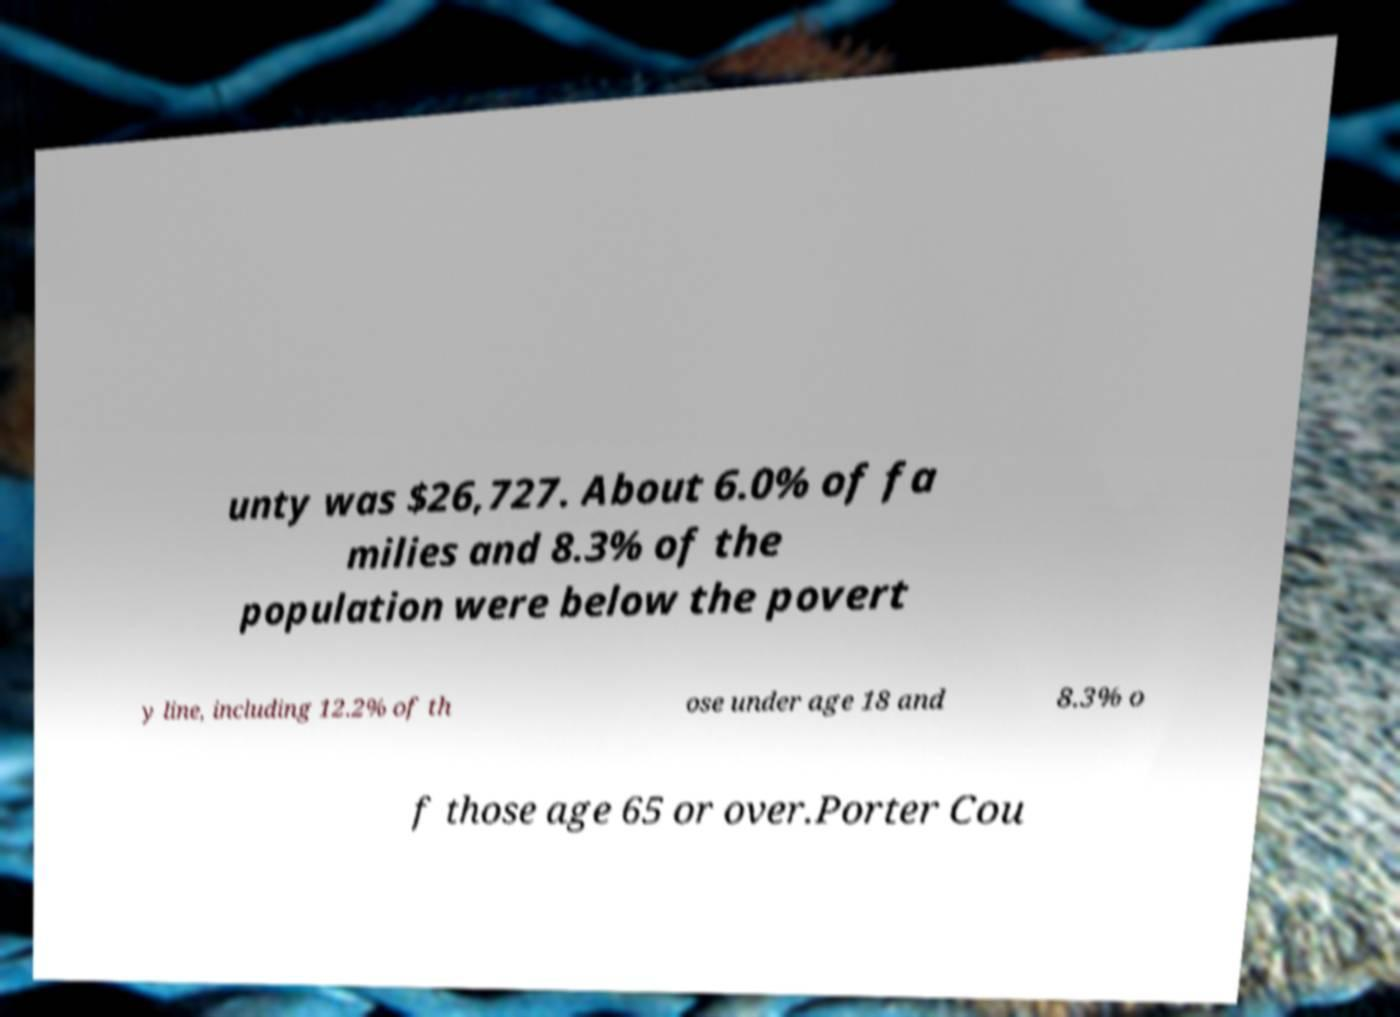Could you extract and type out the text from this image? unty was $26,727. About 6.0% of fa milies and 8.3% of the population were below the povert y line, including 12.2% of th ose under age 18 and 8.3% o f those age 65 or over.Porter Cou 